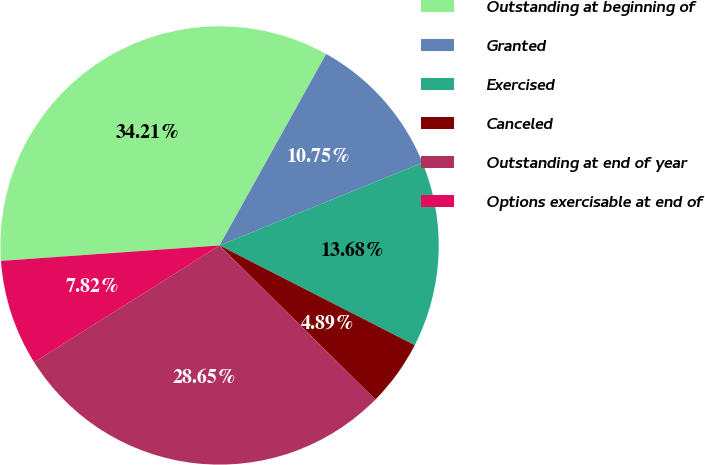Convert chart. <chart><loc_0><loc_0><loc_500><loc_500><pie_chart><fcel>Outstanding at beginning of<fcel>Granted<fcel>Exercised<fcel>Canceled<fcel>Outstanding at end of year<fcel>Options exercisable at end of<nl><fcel>34.2%<fcel>10.75%<fcel>13.68%<fcel>4.89%<fcel>28.64%<fcel>7.82%<nl></chart> 